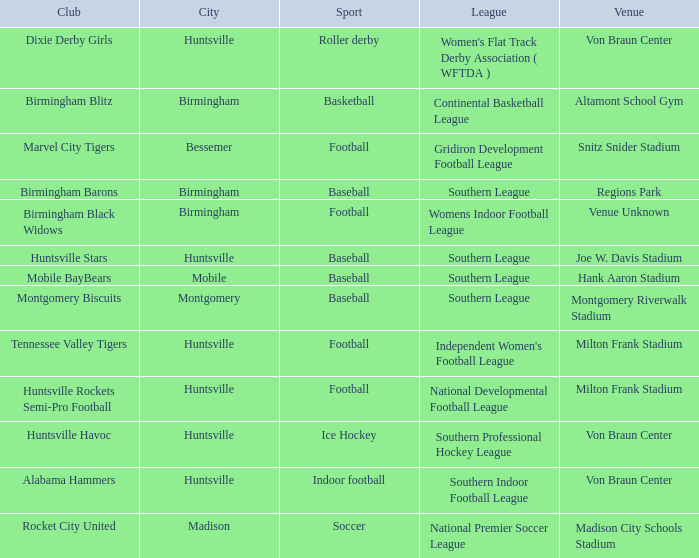Which sport was held in Huntsville at the Von Braun Center as part of the Southern Indoor Football League? Indoor football. 